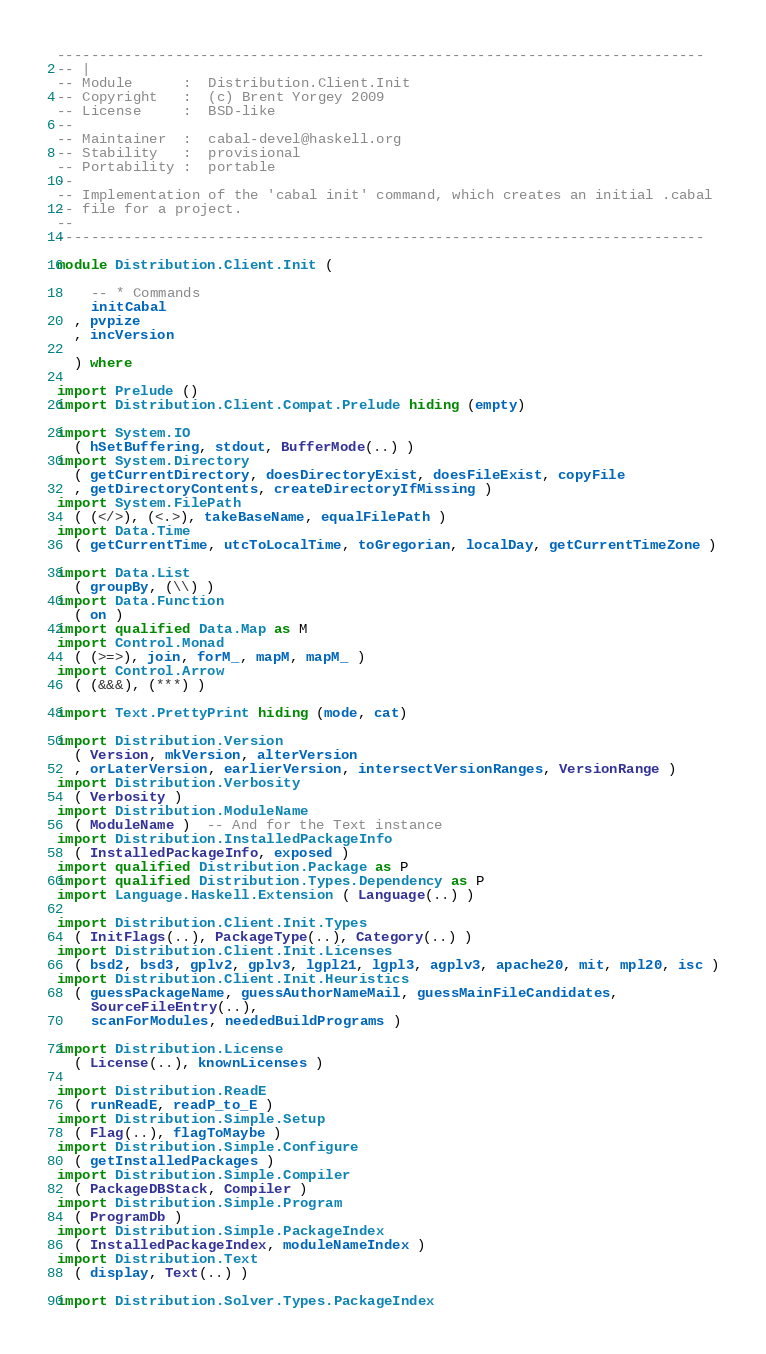<code> <loc_0><loc_0><loc_500><loc_500><_Haskell_>-----------------------------------------------------------------------------
-- |
-- Module      :  Distribution.Client.Init
-- Copyright   :  (c) Brent Yorgey 2009
-- License     :  BSD-like
--
-- Maintainer  :  cabal-devel@haskell.org
-- Stability   :  provisional
-- Portability :  portable
--
-- Implementation of the 'cabal init' command, which creates an initial .cabal
-- file for a project.
--
-----------------------------------------------------------------------------

module Distribution.Client.Init (

    -- * Commands
    initCabal
  , pvpize
  , incVersion

  ) where

import Prelude ()
import Distribution.Client.Compat.Prelude hiding (empty)

import System.IO
  ( hSetBuffering, stdout, BufferMode(..) )
import System.Directory
  ( getCurrentDirectory, doesDirectoryExist, doesFileExist, copyFile
  , getDirectoryContents, createDirectoryIfMissing )
import System.FilePath
  ( (</>), (<.>), takeBaseName, equalFilePath )
import Data.Time
  ( getCurrentTime, utcToLocalTime, toGregorian, localDay, getCurrentTimeZone )

import Data.List
  ( groupBy, (\\) )
import Data.Function
  ( on )
import qualified Data.Map as M
import Control.Monad
  ( (>=>), join, forM_, mapM, mapM_ )
import Control.Arrow
  ( (&&&), (***) )

import Text.PrettyPrint hiding (mode, cat)

import Distribution.Version
  ( Version, mkVersion, alterVersion
  , orLaterVersion, earlierVersion, intersectVersionRanges, VersionRange )
import Distribution.Verbosity
  ( Verbosity )
import Distribution.ModuleName
  ( ModuleName )  -- And for the Text instance
import Distribution.InstalledPackageInfo
  ( InstalledPackageInfo, exposed )
import qualified Distribution.Package as P
import qualified Distribution.Types.Dependency as P
import Language.Haskell.Extension ( Language(..) )

import Distribution.Client.Init.Types
  ( InitFlags(..), PackageType(..), Category(..) )
import Distribution.Client.Init.Licenses
  ( bsd2, bsd3, gplv2, gplv3, lgpl21, lgpl3, agplv3, apache20, mit, mpl20, isc )
import Distribution.Client.Init.Heuristics
  ( guessPackageName, guessAuthorNameMail, guessMainFileCandidates,
    SourceFileEntry(..),
    scanForModules, neededBuildPrograms )

import Distribution.License
  ( License(..), knownLicenses )

import Distribution.ReadE
  ( runReadE, readP_to_E )
import Distribution.Simple.Setup
  ( Flag(..), flagToMaybe )
import Distribution.Simple.Configure
  ( getInstalledPackages )
import Distribution.Simple.Compiler
  ( PackageDBStack, Compiler )
import Distribution.Simple.Program
  ( ProgramDb )
import Distribution.Simple.PackageIndex
  ( InstalledPackageIndex, moduleNameIndex )
import Distribution.Text
  ( display, Text(..) )

import Distribution.Solver.Types.PackageIndex</code> 